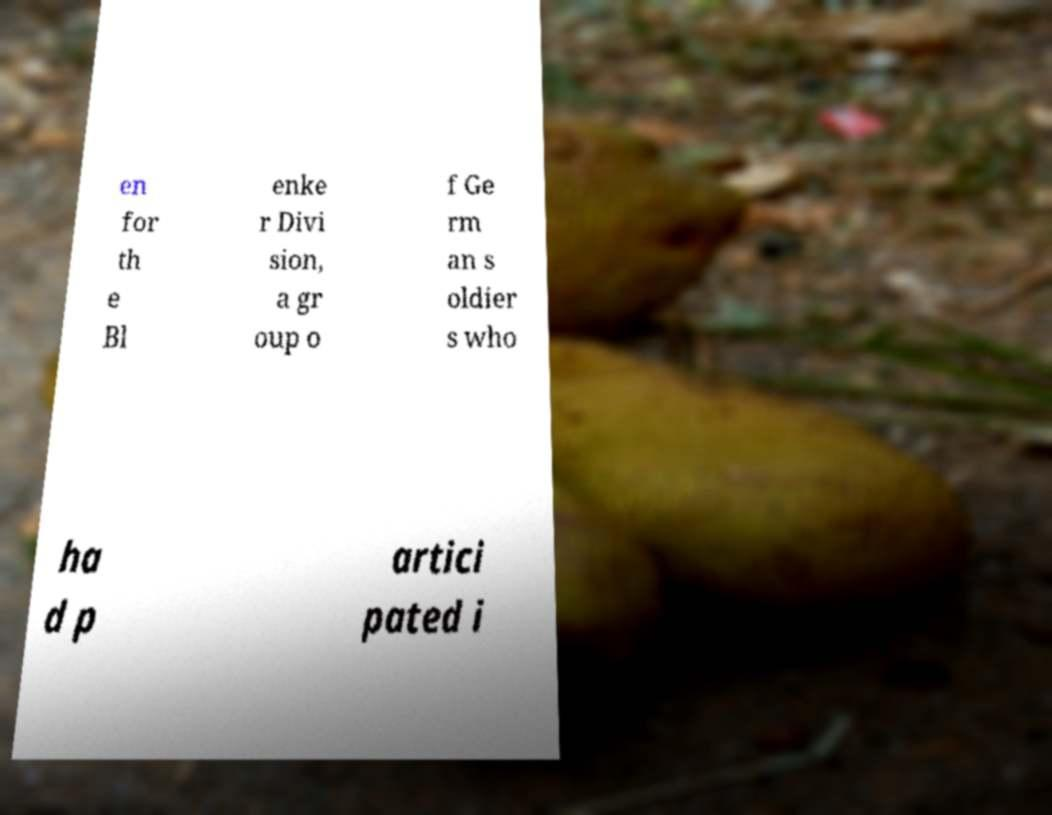For documentation purposes, I need the text within this image transcribed. Could you provide that? en for th e Bl enke r Divi sion, a gr oup o f Ge rm an s oldier s who ha d p artici pated i 